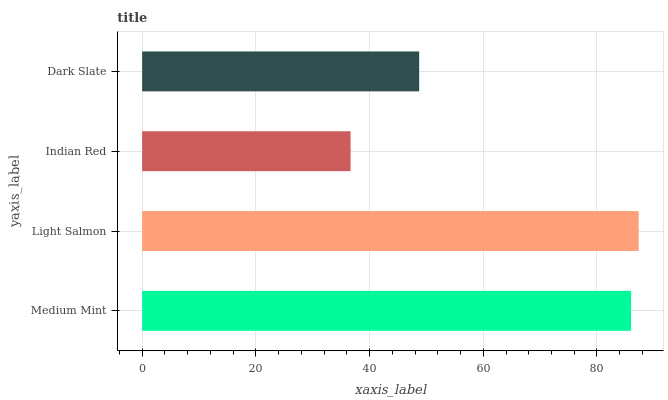Is Indian Red the minimum?
Answer yes or no. Yes. Is Light Salmon the maximum?
Answer yes or no. Yes. Is Light Salmon the minimum?
Answer yes or no. No. Is Indian Red the maximum?
Answer yes or no. No. Is Light Salmon greater than Indian Red?
Answer yes or no. Yes. Is Indian Red less than Light Salmon?
Answer yes or no. Yes. Is Indian Red greater than Light Salmon?
Answer yes or no. No. Is Light Salmon less than Indian Red?
Answer yes or no. No. Is Medium Mint the high median?
Answer yes or no. Yes. Is Dark Slate the low median?
Answer yes or no. Yes. Is Indian Red the high median?
Answer yes or no. No. Is Light Salmon the low median?
Answer yes or no. No. 